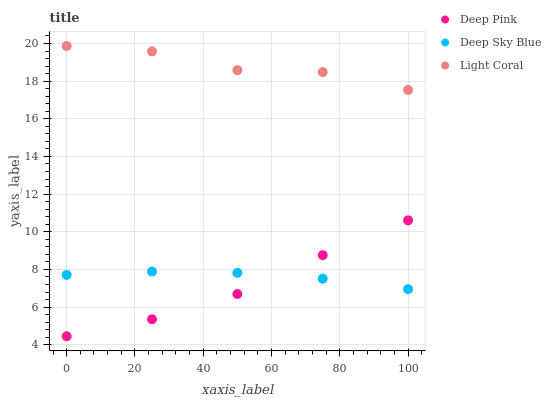Does Deep Pink have the minimum area under the curve?
Answer yes or no. Yes. Does Light Coral have the maximum area under the curve?
Answer yes or no. Yes. Does Deep Sky Blue have the minimum area under the curve?
Answer yes or no. No. Does Deep Sky Blue have the maximum area under the curve?
Answer yes or no. No. Is Deep Sky Blue the smoothest?
Answer yes or no. Yes. Is Light Coral the roughest?
Answer yes or no. Yes. Is Deep Pink the smoothest?
Answer yes or no. No. Is Deep Pink the roughest?
Answer yes or no. No. Does Deep Pink have the lowest value?
Answer yes or no. Yes. Does Deep Sky Blue have the lowest value?
Answer yes or no. No. Does Light Coral have the highest value?
Answer yes or no. Yes. Does Deep Pink have the highest value?
Answer yes or no. No. Is Deep Pink less than Light Coral?
Answer yes or no. Yes. Is Light Coral greater than Deep Pink?
Answer yes or no. Yes. Does Deep Pink intersect Deep Sky Blue?
Answer yes or no. Yes. Is Deep Pink less than Deep Sky Blue?
Answer yes or no. No. Is Deep Pink greater than Deep Sky Blue?
Answer yes or no. No. Does Deep Pink intersect Light Coral?
Answer yes or no. No. 